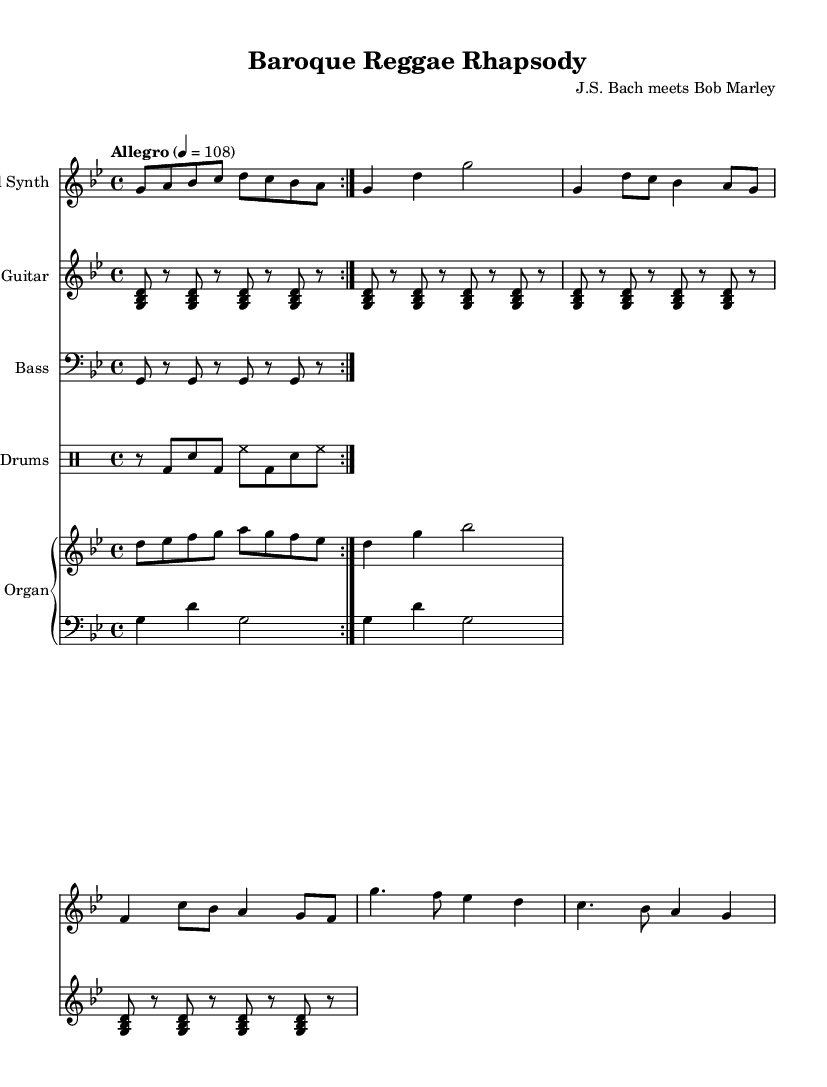What is the key signature of this music? The key signature is G minor, which has two flats: B flat and E flat. This can be determined by looking at the key signature at the start of the staff.
Answer: G minor What is the time signature of this music? The time signature is 4/4, indicated by the "4/4" notation at the beginning of the score, showing that there are four beats in a measure.
Answer: 4/4 What is the tempo marking of this piece? The tempo marking is "Allegro," which indicates a fast and lively speed, usually ranging from 120 to 168 beats per minute. It is specified at the beginning of the score.
Answer: Allegro How many measures are in the lead synth part? The lead synth part consists of 8 measures as counted from the notation provided, where each measure is separated by a vertical bar.
Answer: 8 measures What type of rhythmic pattern is used in the electric guitar part? The electric guitar part employs a simple reggae rhythm, which is characterized by the offbeat staccato chords that create a distinctive reggae feel. This is seen in the repeated chord sequence throughout the part.
Answer: Simple reggae rhythm What genre fusion is represented in this composition? This composition represents a fusion of Baroque and reggae, combining elements of Baroque music structure, such as counterpoint and harmony, with reggae's distinctive rhythm and feel. The title also reflects this fusion.
Answer: Baroque and reggae 